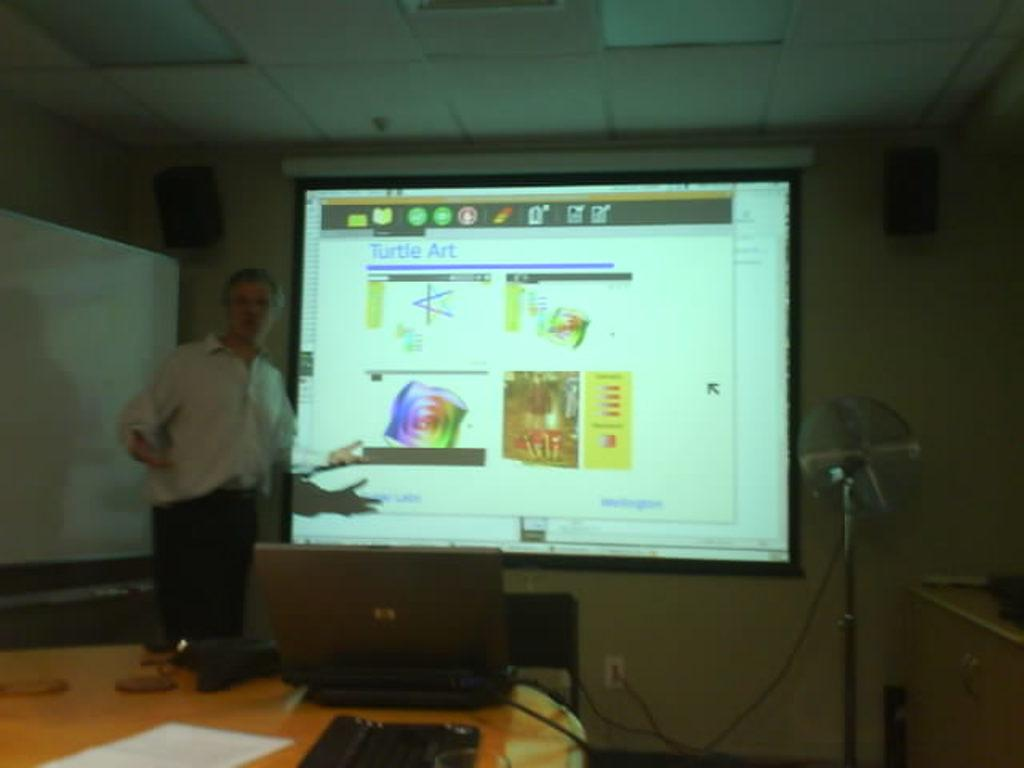What is on the wall in the image? There is a screen on the wall. What can be seen near the screen? There is a fan with a stand and a person standing in front of the screen. What is on the table in the image? There is a laptop, paper, and a keyboard on the table. Is there any audio equipment in the image? Yes, there is a speaker on top of the screen or another object. Can you see a plane flying in the image? No, there is no plane visible in the image. Is there a bucket of water on the table? No, there is no bucket present in the image. 